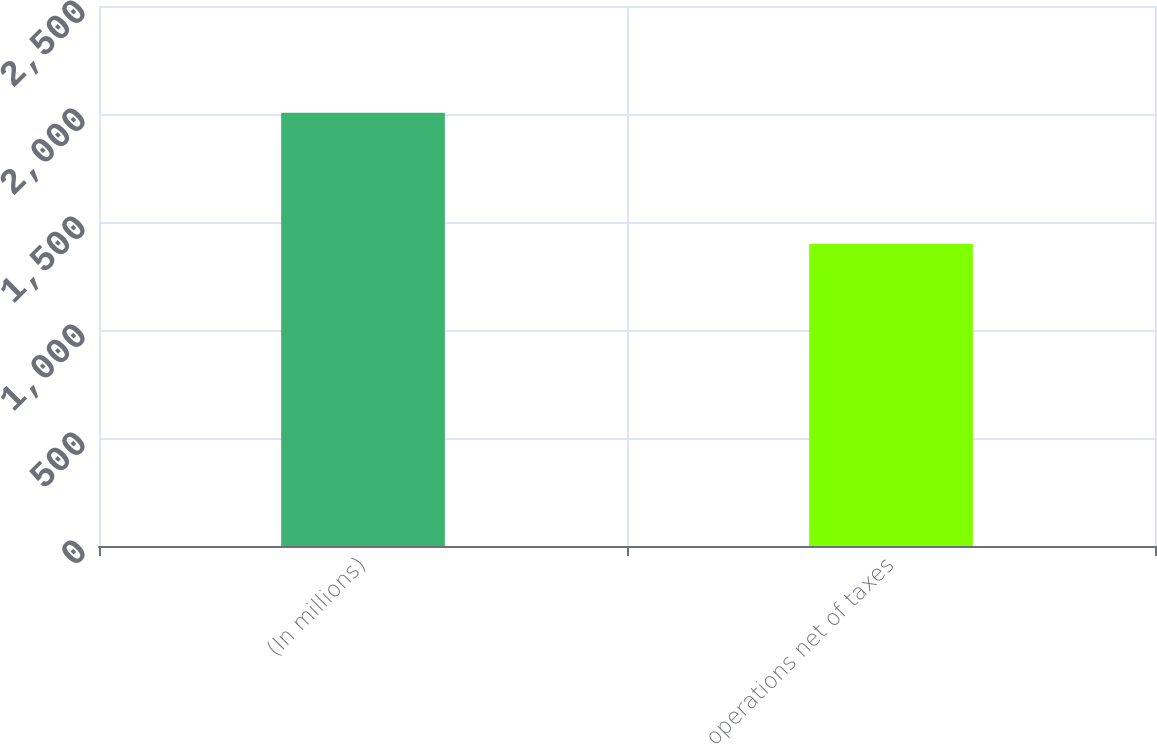Convert chart. <chart><loc_0><loc_0><loc_500><loc_500><bar_chart><fcel>(In millions)<fcel>operations net of taxes<nl><fcel>2006<fcel>1398<nl></chart> 